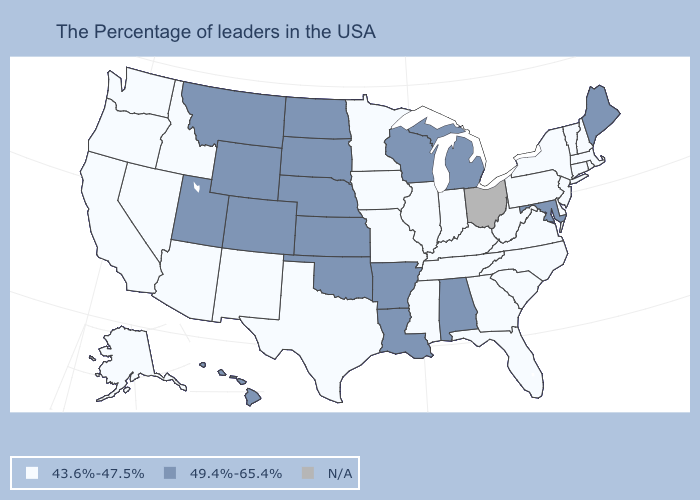Is the legend a continuous bar?
Concise answer only. No. Which states hav the highest value in the MidWest?
Answer briefly. Michigan, Wisconsin, Kansas, Nebraska, South Dakota, North Dakota. Which states have the lowest value in the USA?
Give a very brief answer. Massachusetts, Rhode Island, New Hampshire, Vermont, Connecticut, New York, New Jersey, Delaware, Pennsylvania, Virginia, North Carolina, South Carolina, West Virginia, Florida, Georgia, Kentucky, Indiana, Tennessee, Illinois, Mississippi, Missouri, Minnesota, Iowa, Texas, New Mexico, Arizona, Idaho, Nevada, California, Washington, Oregon, Alaska. Is the legend a continuous bar?
Keep it brief. No. Name the states that have a value in the range 49.4%-65.4%?
Keep it brief. Maine, Maryland, Michigan, Alabama, Wisconsin, Louisiana, Arkansas, Kansas, Nebraska, Oklahoma, South Dakota, North Dakota, Wyoming, Colorado, Utah, Montana, Hawaii. What is the value of Ohio?
Answer briefly. N/A. Name the states that have a value in the range N/A?
Quick response, please. Ohio. What is the highest value in states that border Minnesota?
Write a very short answer. 49.4%-65.4%. Name the states that have a value in the range N/A?
Quick response, please. Ohio. Name the states that have a value in the range N/A?
Concise answer only. Ohio. What is the value of Louisiana?
Short answer required. 49.4%-65.4%. What is the value of Texas?
Short answer required. 43.6%-47.5%. Does the map have missing data?
Give a very brief answer. Yes. 